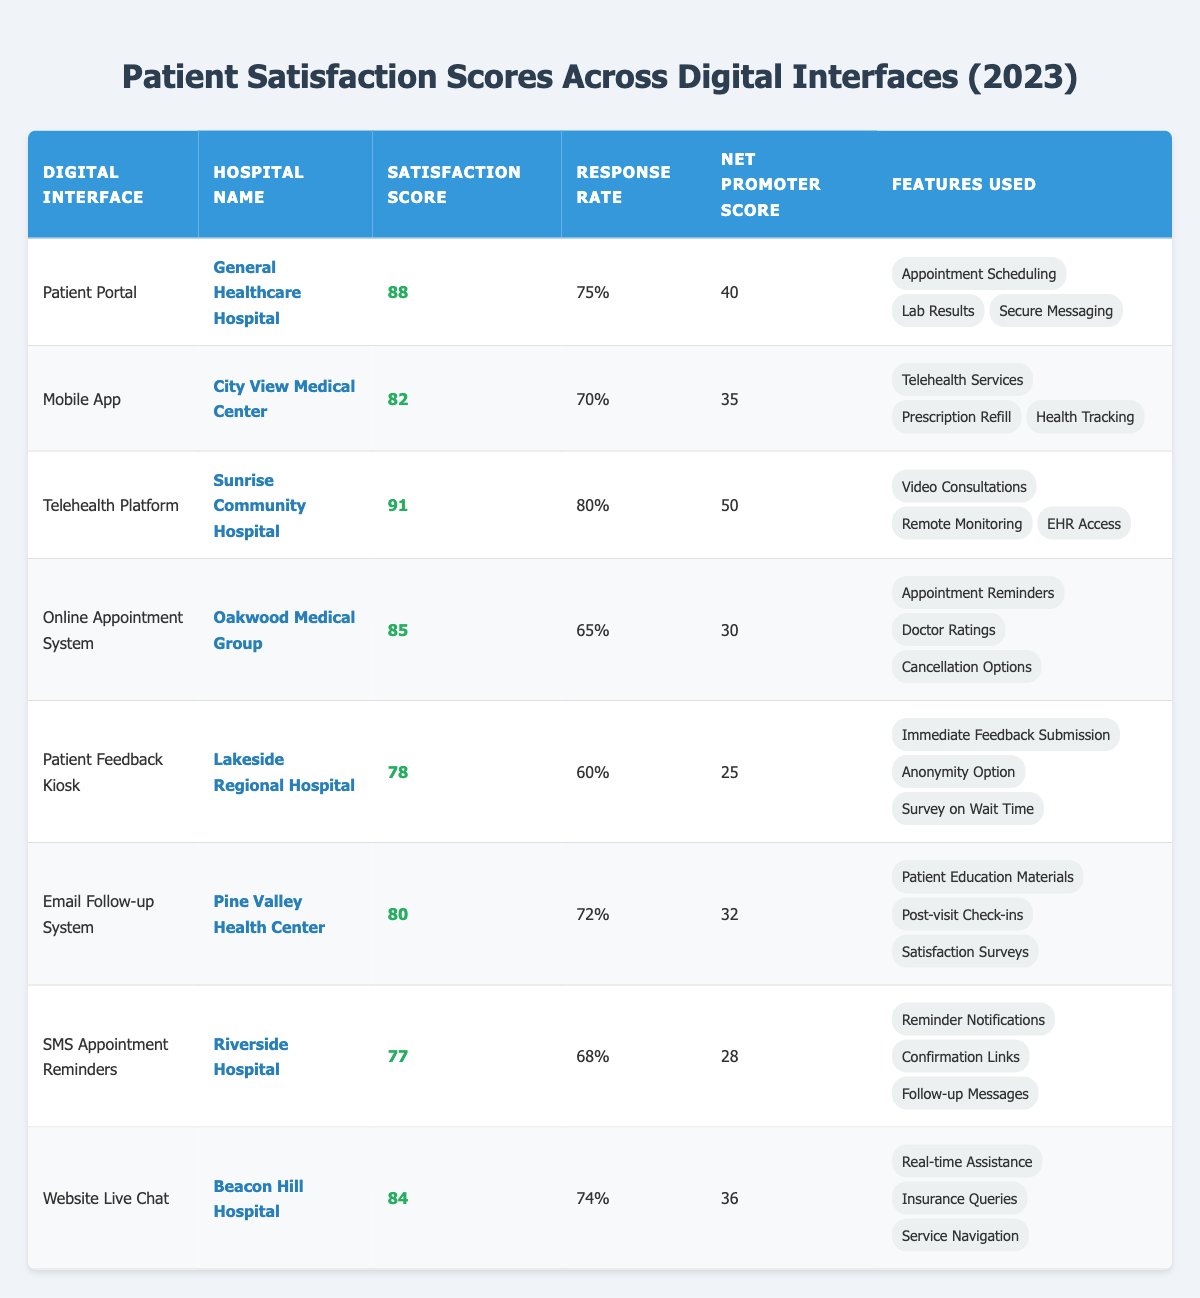What is the highest patient satisfaction score among the digital interfaces? The highest satisfaction score in the table is found by comparing all the satisfaction scores listed. The scores are 88 for Patient Portal, 82 for Mobile App, 91 for Telehealth Platform, 85 for Online Appointment System, 78 for Patient Feedback Kiosk, 80 for Email Follow-up System, 77 for SMS Appointment Reminders, and 84 for Website Live Chat. The highest score is 91 for the Telehealth Platform.
Answer: 91 Which hospital has the lowest response rate? To find the lowest response rate, look at the Response Rate column and identify the smallest percentage. The response rates are 75% for General Healthcare Hospital, 70% for City View Medical Center, 80% for Sunrise Community Hospital, 65% for Oakwood Medical Group, 60% for Lakeside Regional Hospital, 72% for Pine Valley Health Center, 68% for Riverside Hospital, and 74% for Beacon Hill Hospital. The lowest response rate is 60% for Lakeside Regional Hospital.
Answer: Lakeside Regional Hospital What is the Net Promoter Score (NPS) for the Mobile App? The Net Promoter Score for the Mobile App can be directly retrieved from the table. It shows 35 as the NPS for the Mobile App used at City View Medical Center.
Answer: 35 What is the average satisfaction score for all digital interfaces? To calculate the average satisfaction score, sum all the satisfaction scores: 88 + 82 + 91 + 85 + 78 + 80 + 77 + 84 = 585. Then divide by the number of interfaces (8) to find the average: 585 / 8 = 73.125.
Answer: 73.125 Is there a digital interface with a satisfaction score above 85? By checking the Satisfaction Score column, we can see that there are three scores above 85: 88 (Patient Portal), 91 (Telehealth Platform), and 85 (Online Appointment System). Therefore, there are indeed interfaces with satisfaction scores above 85.
Answer: Yes Which digital interface has the highest Net Promoter Score? To determine which interface has the highest Net Promoter Score, compare the NPS values of all interfaces: 40 for Patient Portal, 35 for Mobile App, 50 for Telehealth Platform, 30 for Online Appointment System, 25 for Patient Feedback Kiosk, 32 for Email Follow-up System, 28 for SMS Appointment Reminders, and 36 for Website Live Chat. The highest is 50 for the Telehealth Platform.
Answer: Telehealth Platform How many features were listed for the Patient Feedback Kiosk? The number of features for the Patient Feedback Kiosk can be directly counted from the features listed under that digital interface in the table. There are three features: "Immediate Feedback Submission," "Anonymity Option," and "Survey on Wait Time."
Answer: 3 Which hospital’s digital interface has the highest satisfaction score among those with a response rate over 70%? First, identify interfaces with a response rate greater than 70%. These are the Patient Portal (75%), Telehealth Platform (80%), Mobile App (70%), and Email Follow-up System (72%). Their satisfaction scores are 88, 91, 82, and 80 respectively. The highest of these is 91 for the Telehealth Platform at Sunrise Community Hospital.
Answer: Sunrise Community Hospital (Telehealth Platform) What is the difference between the highest and lowest satisfaction scores? To find the difference, subtract the lowest satisfaction score (78 for Patient Feedback Kiosk) from the highest satisfaction score (91 for Telehealth Platform): 91 - 78 = 13.
Answer: 13 Does any digital interface have a higher satisfaction score than the Patient Portal? Comparing the satisfaction scores, 88 for Patient Portal and the others: 82 (Mobile App), 91 (Telehealth Platform), 85 (Online Appointment System), 78 (Patient Feedback Kiosk), 80 (Email Follow-up System), 77 (SMS Appointment Reminders), and 84 (Website Live Chat). The Telehealth Platform has a higher score than the Patient Portal.
Answer: Yes 